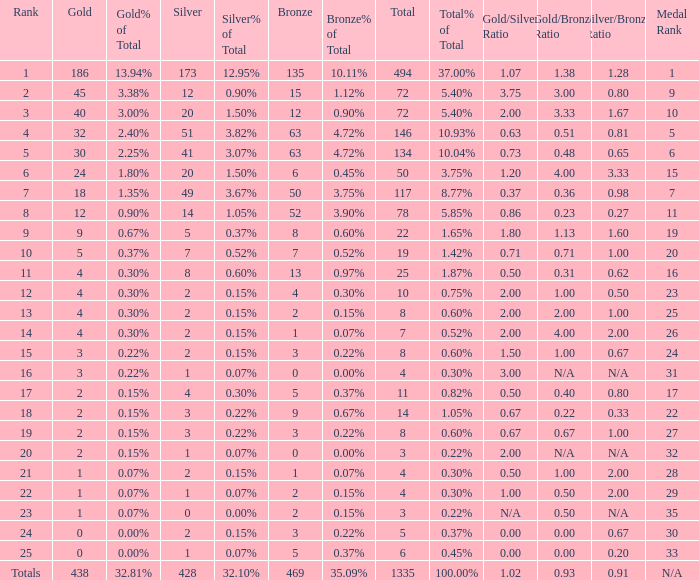What is the number of bronze medals when the total medals were 78 and there were less than 12 golds? None. 